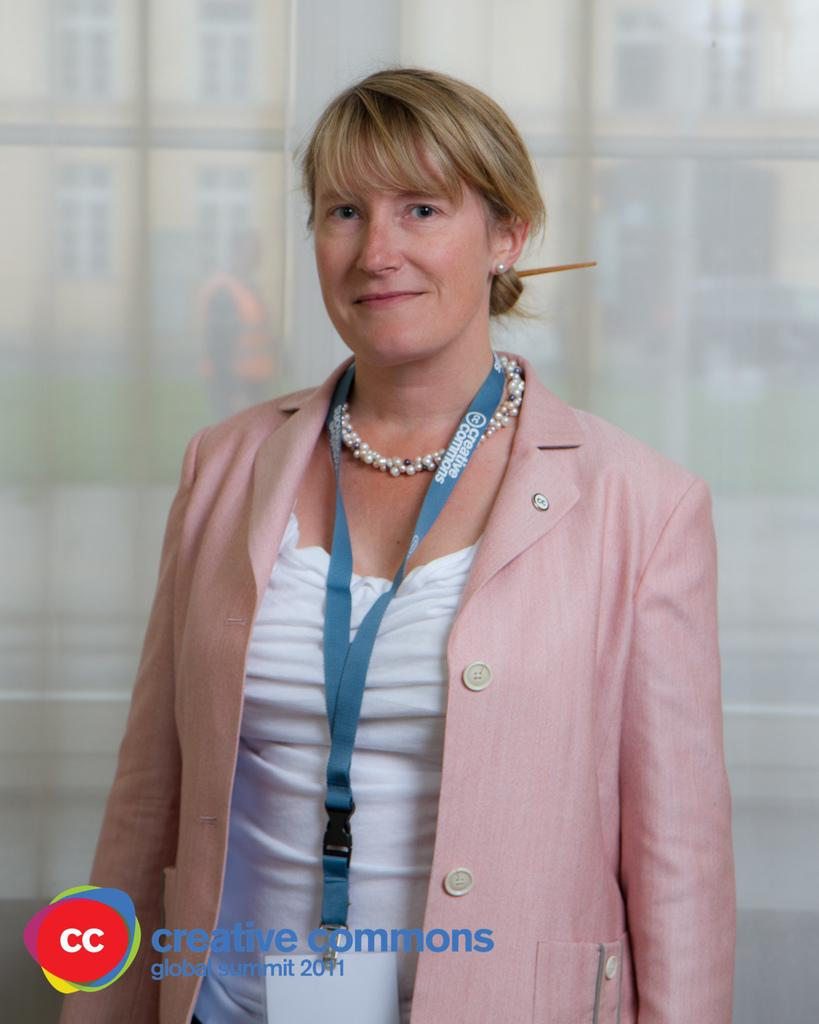Who is the main subject in the image? There is a woman in the image. What is the woman standing in front of? The woman is standing in front of a glass wall. Can you describe any additional features of the image? There is a water mark at the bottom of the image. What type of lead can be seen in the woman's hand in the image? There is no lead present in the image, and the woman's hands are not visible. 